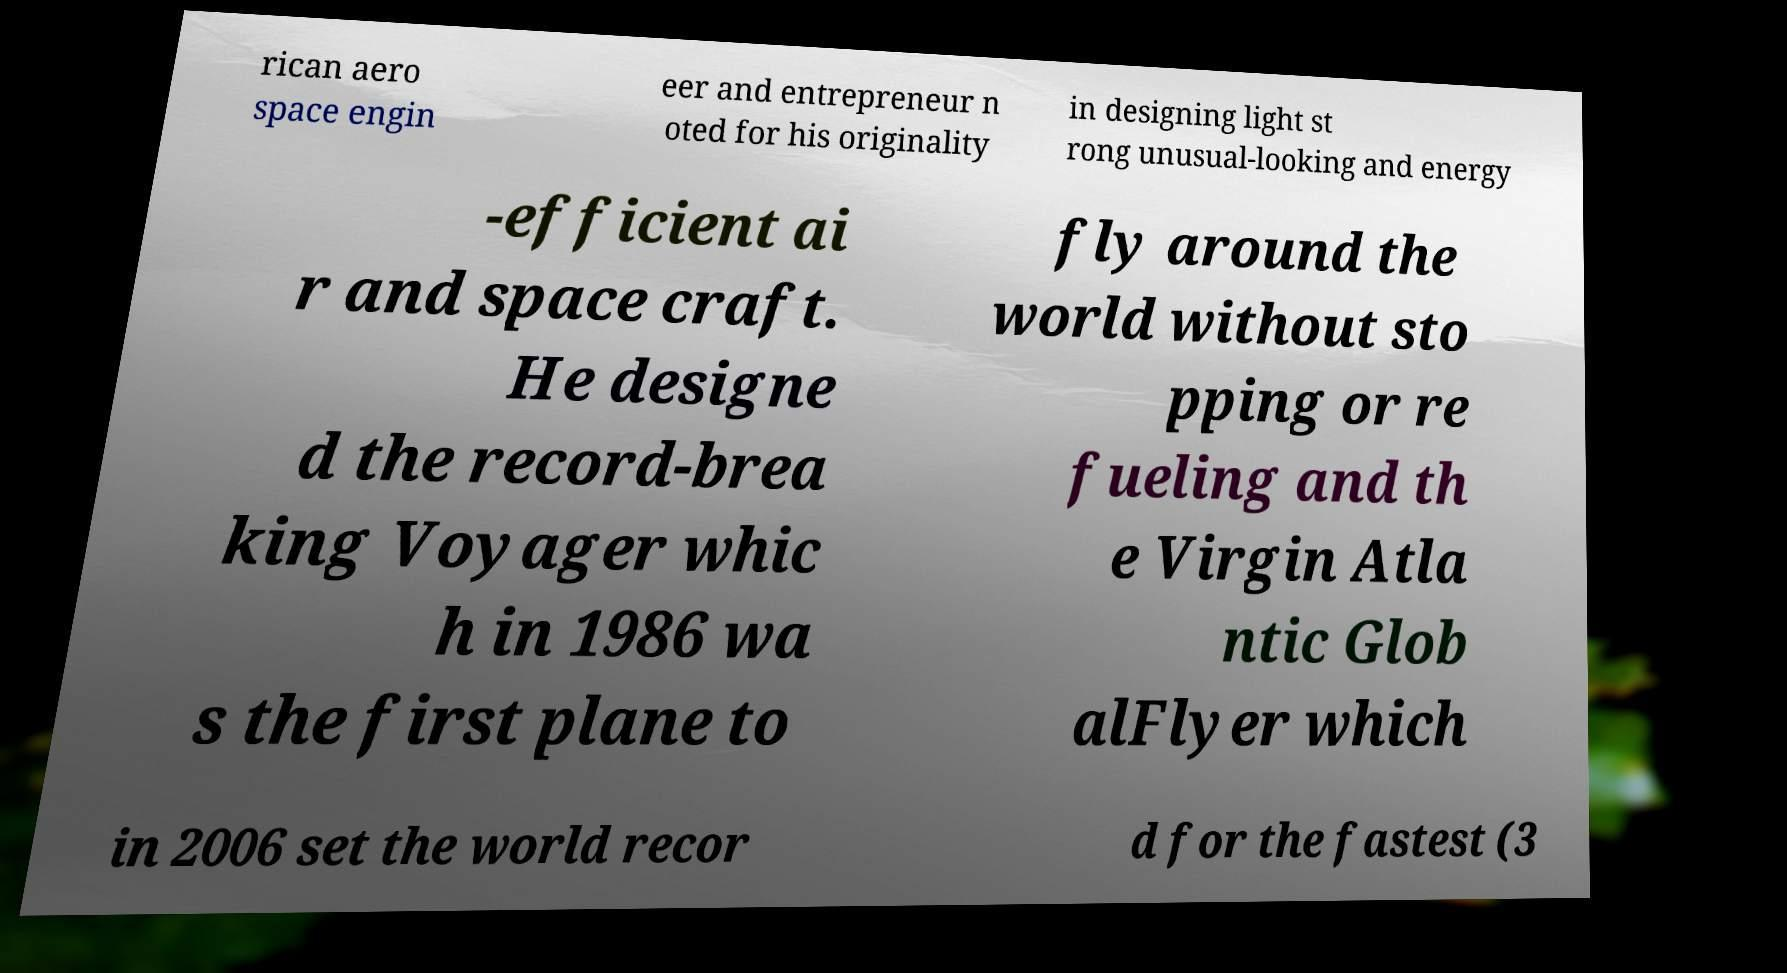Please read and relay the text visible in this image. What does it say? rican aero space engin eer and entrepreneur n oted for his originality in designing light st rong unusual-looking and energy -efficient ai r and space craft. He designe d the record-brea king Voyager whic h in 1986 wa s the first plane to fly around the world without sto pping or re fueling and th e Virgin Atla ntic Glob alFlyer which in 2006 set the world recor d for the fastest (3 